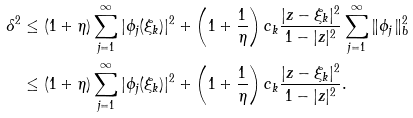<formula> <loc_0><loc_0><loc_500><loc_500>\delta ^ { 2 } & \leq ( 1 + \eta ) \sum _ { j = 1 } ^ { \infty } | \phi _ { j } ( \xi _ { k } ) | ^ { 2 } + \left ( 1 + \frac { 1 } { \eta } \right ) c _ { k } \frac { | z - \xi _ { k } | ^ { 2 } } { 1 - | z | ^ { 2 } } \sum _ { j = 1 } ^ { \infty } \| \phi _ { j } \| _ { b } ^ { 2 } \\ & \leq ( 1 + \eta ) \sum _ { j = 1 } ^ { \infty } | \phi _ { j } ( \xi _ { k } ) | ^ { 2 } + \left ( 1 + \frac { 1 } { \eta } \right ) c _ { k } \frac { | z - \xi _ { k } | ^ { 2 } } { 1 - | z | ^ { 2 } } .</formula> 